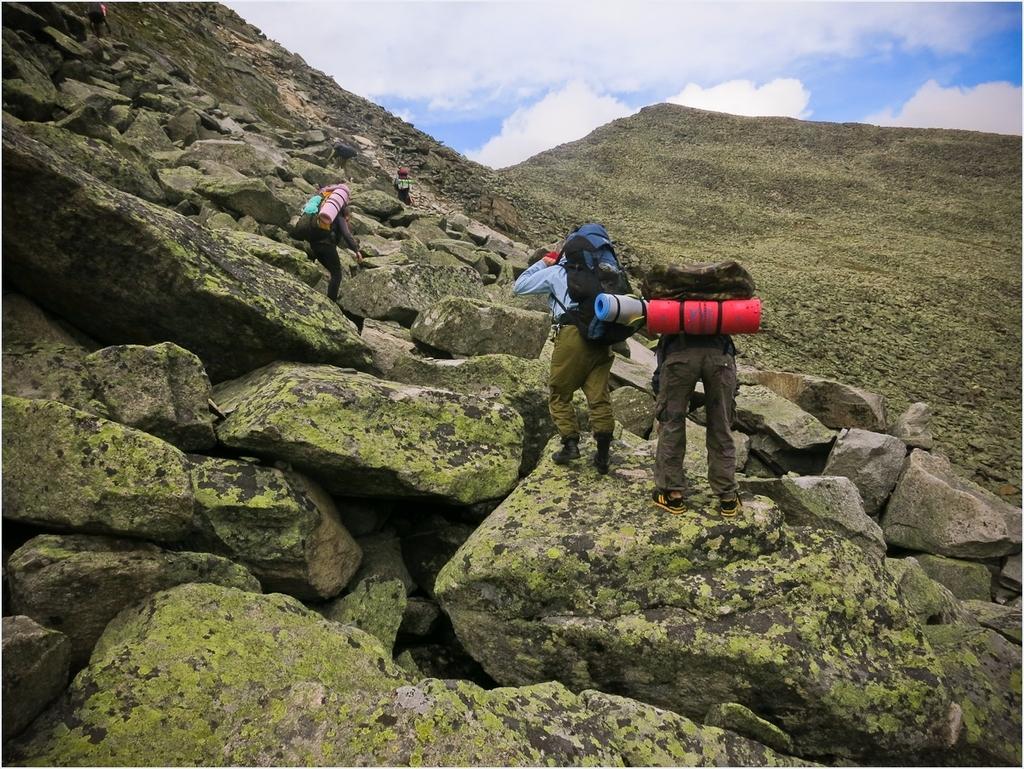Describe this image in one or two sentences. In this image I can see three people with different color dresses. I can see these people are wearing the bags and some objects. They are standing on the rocks. In the background I can see the mountains, clouds and the sky. 